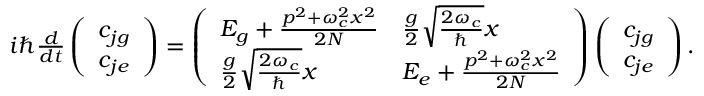Convert formula to latex. <formula><loc_0><loc_0><loc_500><loc_500>\begin{array} { r } { i \hbar { } d } { d t } \left ( \begin{array} { l } { c _ { j g } } \\ { c _ { j e } } \end{array} \right ) = \left ( \begin{array} { l l } { E _ { g } + \frac { p ^ { 2 } + \omega _ { c } ^ { 2 } x ^ { 2 } } { 2 N } } & { \frac { g } { 2 } \sqrt { \frac { 2 \omega _ { c } } { } } x } \\ { \frac { g } { 2 } \sqrt { \frac { 2 \omega _ { c } } { } } x } & { E _ { e } + \frac { p ^ { 2 } + \omega _ { c } ^ { 2 } x ^ { 2 } } { 2 N } } \end{array} \right ) \left ( \begin{array} { l } { c _ { j g } } \\ { c _ { j e } } \end{array} \right ) . } \end{array}</formula> 